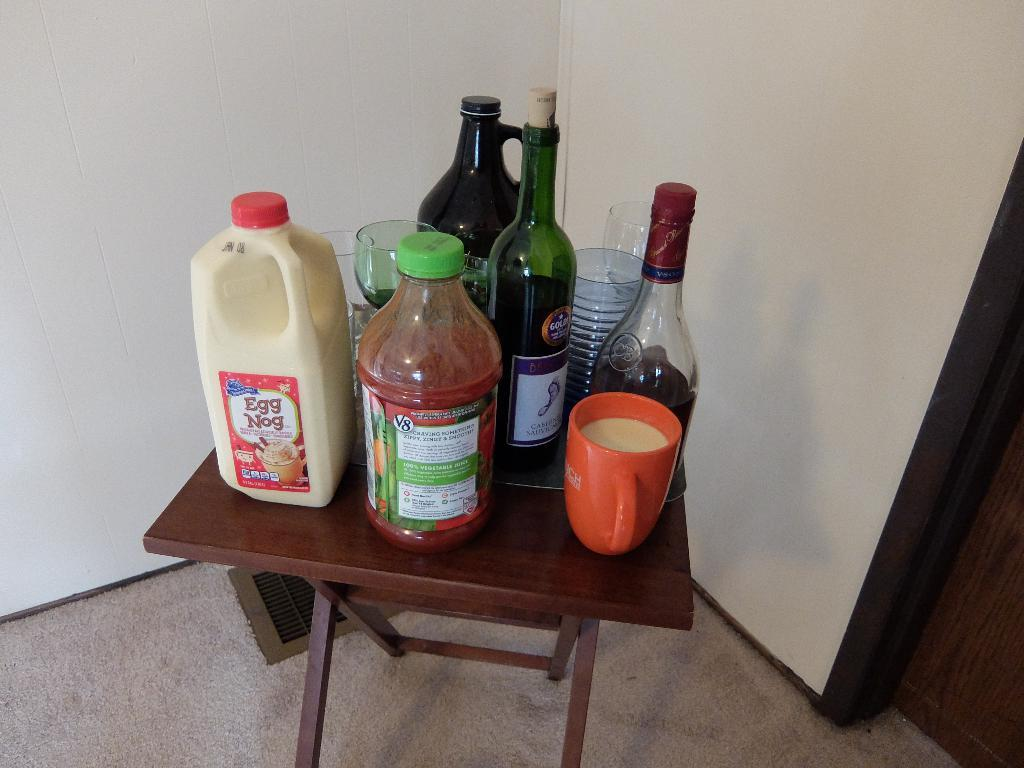<image>
Summarize the visual content of the image. the words egg nog are on a bottle 